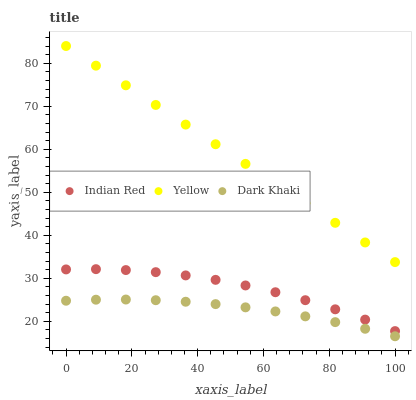Does Dark Khaki have the minimum area under the curve?
Answer yes or no. Yes. Does Yellow have the maximum area under the curve?
Answer yes or no. Yes. Does Indian Red have the minimum area under the curve?
Answer yes or no. No. Does Indian Red have the maximum area under the curve?
Answer yes or no. No. Is Yellow the smoothest?
Answer yes or no. Yes. Is Indian Red the roughest?
Answer yes or no. Yes. Is Indian Red the smoothest?
Answer yes or no. No. Is Yellow the roughest?
Answer yes or no. No. Does Dark Khaki have the lowest value?
Answer yes or no. Yes. Does Indian Red have the lowest value?
Answer yes or no. No. Does Yellow have the highest value?
Answer yes or no. Yes. Does Indian Red have the highest value?
Answer yes or no. No. Is Indian Red less than Yellow?
Answer yes or no. Yes. Is Indian Red greater than Dark Khaki?
Answer yes or no. Yes. Does Indian Red intersect Yellow?
Answer yes or no. No. 